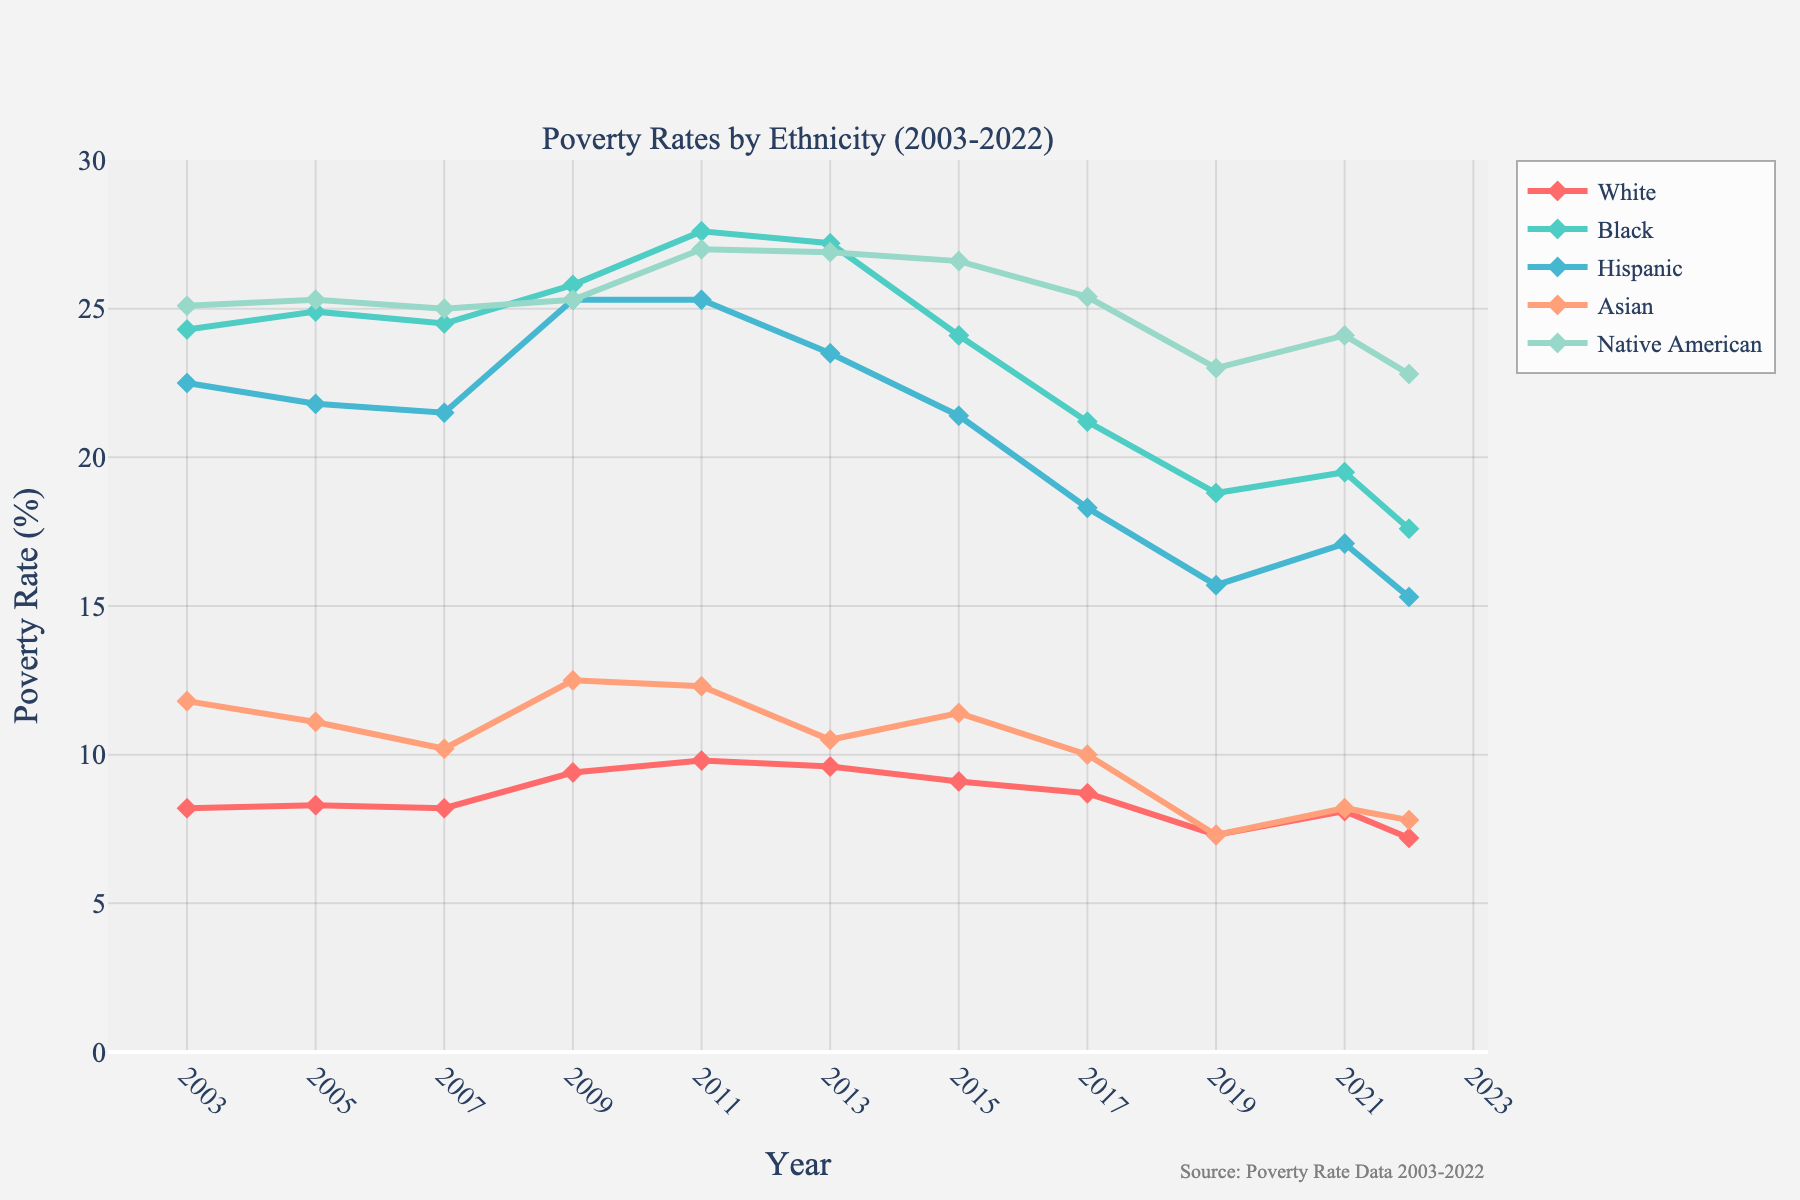Which ethnic group experienced the highest poverty rate in 2011? The highest poverty rate in 2011 can be determined by looking at the peaks of the lines and identifying which line is at the top. In 2011, the Native American group has the highest poverty rate among all the ethnic groups.
Answer: Native American Compare the poverty rate trend of Black and Hispanic ethnicities from 2003 to 2022. Which group shows a greater reduction? To compare the trends, determine the initial and final values of the poverty rates for both ethnicities. Black: 24.3% (2003) to 17.6% (2022), reduction of 6.7%. Hispanic: 22.5% (2003) to 15.3% (2022), reduction of 7.2%. The Hispanic group shows a greater reduction in poverty rates over the period.
Answer: Hispanic In which year did the Asian group experience the lowest poverty rate? To find the lowest point in the data for the Asian group, examine the line and identify the lowest point on the y-axis. The lowest rate for the Asian group occurred in 2022 with a poverty rate of 7.8%.
Answer: 2022 What is the average poverty rate for the White group from 2003 to 2022? To calculate the average, sum all the White group’s poverty rates from each year and divide by the number of years (20). Sum = 8.2 + 8.3 + 8.2 + 9.4 + 9.8 + 9.6 + 9.1 + 8.7 + 7.3 + 8.1 + 7.2 = 94.9. Average = 94.9 / 11 = 8.63%.
Answer: 8.63% What is the highest poverty rate that the Black ethnic group reached, and in which year did it occur? Identify the highest point on the Black group's line and find the corresponding year. The highest poverty rate for the Black group occurred in 2011 at 27.6%.
Answer: 27.6% in 2011 Is there any ethnic group whose poverty rate was consistently below 10%? To answer this, observe the lines for each ethnic group to see if any line consistently stays below the 10% mark across all years. The White group has a poverty rate consistently below 10% except for the years 2009, 2011, and 2013. Hence no ethnic group is consistently below 10%.
Answer: No How does the poverty rate of Native American communities in 2021 compare with their poverty rate in 2003? To compare the rates, find the poverty rates for Native Americans in 2003 (25.1%) and in 2021 (24.1%). The rate decreased slightly by 1 percentage point.
Answer: Decreased by 1 percentage point What is the difference in poverty rates between the highest and the lowest ethnic group in 2007? Identify the highest and lowest poverty rates among the ethnic groups in 2007. The highest is Native American at 25.0%, and the lowest is White at 8.2%. The difference is 25.0% - 8.2% = 16.8%.
Answer: 16.8% Which ethnic group had the sharpest decline in poverty rates between the years 2009 and 2019? Calculate the difference in poverty rates for each ethnic group between 2009 and 2019. White: 9.4% to 7.3% (-2.1%), Black: 25.8% to 18.8% (-7.0%), Hispanic: 25.3% to 15.7% (-9.6%), Asian: 12.5% to 7.3% (-5.2%), Native American: 25.3% to 23.0% (-2.3%). Hispanic had the sharpest decline of -9.6%.
Answer: Hispanic In which year did most ethnic groups experience a drop in poverty rates compared to the previous year? Observe the lines and identify the year where the majority of the ethnic groups show a descending slope from the previous year. In 2019, a majority of the ethnic groups including White, Black, Hispanic, and Native American saw declines.
Answer: 2019 